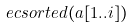Convert formula to latex. <formula><loc_0><loc_0><loc_500><loc_500>& \ e c { s o r t e d ( a [ 1 . . i ] ) }</formula> 